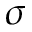<formula> <loc_0><loc_0><loc_500><loc_500>\sigma</formula> 